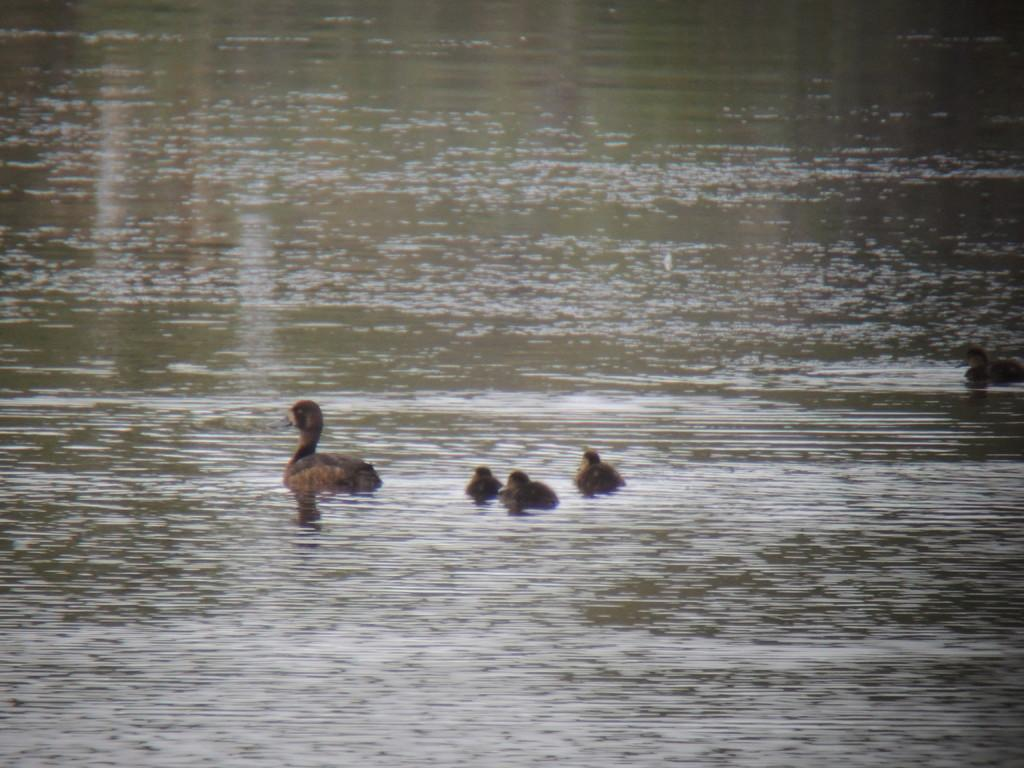Where was the image taken? The image was clicked outside the city. What is the main subject in the center of the image? There is a bird in the center of the image. What can be seen in the water body in the image? There are other objects in the water body. Can you see a hen in the grass in the image? There is no hen or grass present in the image. 